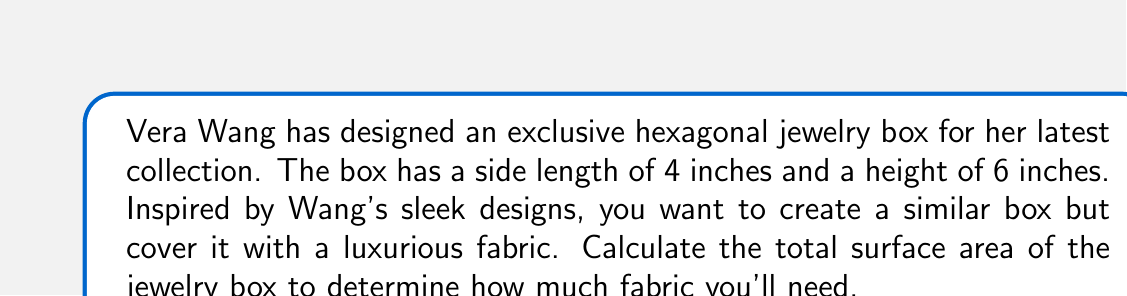What is the answer to this math problem? To calculate the surface area of the hexagonal jewelry box, we need to consider all its faces:

1. The top and bottom faces:
   - These are regular hexagons
   - Area of a regular hexagon: $A = \frac{3\sqrt{3}}{2}s^2$, where $s$ is the side length
   - $A_{top} = A_{bottom} = \frac{3\sqrt{3}}{2}(4^2) = 24\sqrt{3}$ sq inches

2. The lateral faces:
   - These are rectangles
   - Area of each rectangle: $A_{rectangle} = l \times w$, where $l$ is the side length and $w$ is the height
   - $A_{rectangle} = 4 \times 6 = 24$ sq inches
   - There are 6 lateral faces

Now, let's sum up all the areas:

$$\begin{align*}
\text{Total Surface Area} &= A_{top} + A_{bottom} + 6 \times A_{rectangle} \\
&= 24\sqrt{3} + 24\sqrt{3} + 6 \times 24 \\
&= 48\sqrt{3} + 144 \\
&= 48\sqrt{3} + 144
\end{align*}$$

[asy]
import geometry;

// Define the hexagon
pair[] hexagon = {
  (0,0), (1,0), (1.5,0.866), (1,1.732), (0,1.732), (-0.5,0.866)
};

// Scale the hexagon
hexagon = scale(50)*hexagon;

// Draw the hexagon
for(int i=0; i<6; ++i) {
  draw(hexagon[i]--hexagon[(i+1)%6]);
}

// Draw height lines
draw(hexagon[0]--(hexagon[0].x,hexagon[0].y+150), dashed);
draw(hexagon[1]--(hexagon[1].x,hexagon[1].y+150), dashed);

// Label side and height
label("4\"", (hexagon[0]+hexagon[1])/2, S);
label("6\"", (hexagon[1].x+5,hexagon[1].y+75), E);

// Title
label("Hexagonal Jewelry Box", (50,200), N);
[/asy]
Answer: The total surface area of the hexagonal jewelry box is $48\sqrt{3} + 144$ square inches. 